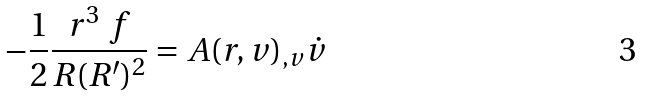Convert formula to latex. <formula><loc_0><loc_0><loc_500><loc_500>- \frac { 1 } { 2 } \frac { r ^ { 3 } \ f } { R ( R ^ { \prime } ) ^ { 2 } } = A ( r , v ) _ { , v } \dot { v }</formula> 